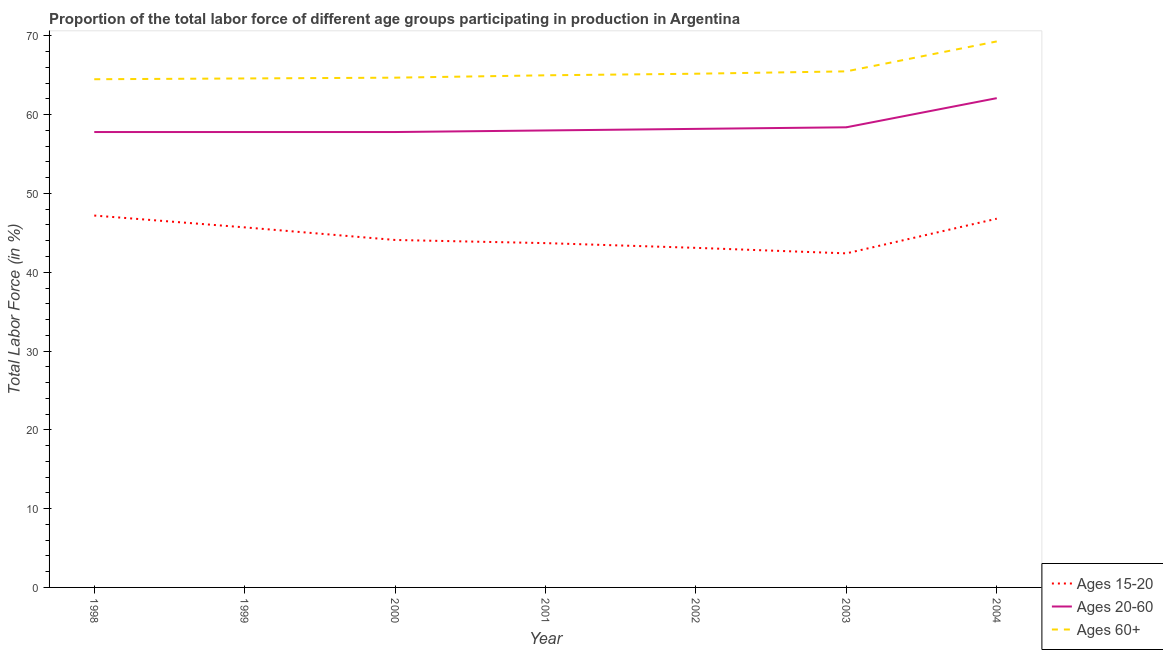Does the line corresponding to percentage of labor force within the age group 15-20 intersect with the line corresponding to percentage of labor force within the age group 20-60?
Provide a short and direct response. No. Is the number of lines equal to the number of legend labels?
Your answer should be compact. Yes. What is the percentage of labor force above age 60 in 1999?
Ensure brevity in your answer.  64.6. Across all years, what is the maximum percentage of labor force within the age group 20-60?
Make the answer very short. 62.1. Across all years, what is the minimum percentage of labor force within the age group 20-60?
Offer a terse response. 57.8. In which year was the percentage of labor force within the age group 20-60 maximum?
Provide a short and direct response. 2004. In which year was the percentage of labor force above age 60 minimum?
Provide a short and direct response. 1998. What is the total percentage of labor force within the age group 15-20 in the graph?
Provide a short and direct response. 313. What is the difference between the percentage of labor force above age 60 in 1999 and that in 2000?
Ensure brevity in your answer.  -0.1. What is the difference between the percentage of labor force above age 60 in 2004 and the percentage of labor force within the age group 15-20 in 2001?
Your answer should be compact. 25.6. What is the average percentage of labor force within the age group 20-60 per year?
Provide a succinct answer. 58.59. In the year 1998, what is the difference between the percentage of labor force above age 60 and percentage of labor force within the age group 20-60?
Offer a very short reply. 6.7. What is the ratio of the percentage of labor force within the age group 15-20 in 1998 to that in 2002?
Make the answer very short. 1.1. What is the difference between the highest and the second highest percentage of labor force within the age group 15-20?
Make the answer very short. 0.4. What is the difference between the highest and the lowest percentage of labor force within the age group 20-60?
Ensure brevity in your answer.  4.3. Is the sum of the percentage of labor force within the age group 15-20 in 2000 and 2002 greater than the maximum percentage of labor force above age 60 across all years?
Provide a short and direct response. Yes. Does the percentage of labor force within the age group 15-20 monotonically increase over the years?
Keep it short and to the point. No. Is the percentage of labor force within the age group 20-60 strictly less than the percentage of labor force within the age group 15-20 over the years?
Offer a terse response. No. Are the values on the major ticks of Y-axis written in scientific E-notation?
Your response must be concise. No. Does the graph contain any zero values?
Provide a short and direct response. No. Does the graph contain grids?
Offer a terse response. No. What is the title of the graph?
Make the answer very short. Proportion of the total labor force of different age groups participating in production in Argentina. Does "Transport" appear as one of the legend labels in the graph?
Keep it short and to the point. No. What is the label or title of the Y-axis?
Keep it short and to the point. Total Labor Force (in %). What is the Total Labor Force (in %) in Ages 15-20 in 1998?
Offer a terse response. 47.2. What is the Total Labor Force (in %) of Ages 20-60 in 1998?
Offer a terse response. 57.8. What is the Total Labor Force (in %) of Ages 60+ in 1998?
Keep it short and to the point. 64.5. What is the Total Labor Force (in %) in Ages 15-20 in 1999?
Offer a terse response. 45.7. What is the Total Labor Force (in %) of Ages 20-60 in 1999?
Offer a very short reply. 57.8. What is the Total Labor Force (in %) in Ages 60+ in 1999?
Provide a short and direct response. 64.6. What is the Total Labor Force (in %) of Ages 15-20 in 2000?
Give a very brief answer. 44.1. What is the Total Labor Force (in %) of Ages 20-60 in 2000?
Your answer should be compact. 57.8. What is the Total Labor Force (in %) in Ages 60+ in 2000?
Give a very brief answer. 64.7. What is the Total Labor Force (in %) of Ages 15-20 in 2001?
Your answer should be compact. 43.7. What is the Total Labor Force (in %) of Ages 20-60 in 2001?
Provide a short and direct response. 58. What is the Total Labor Force (in %) in Ages 60+ in 2001?
Ensure brevity in your answer.  65. What is the Total Labor Force (in %) in Ages 15-20 in 2002?
Provide a succinct answer. 43.1. What is the Total Labor Force (in %) of Ages 20-60 in 2002?
Make the answer very short. 58.2. What is the Total Labor Force (in %) of Ages 60+ in 2002?
Provide a short and direct response. 65.2. What is the Total Labor Force (in %) of Ages 15-20 in 2003?
Make the answer very short. 42.4. What is the Total Labor Force (in %) of Ages 20-60 in 2003?
Your answer should be very brief. 58.4. What is the Total Labor Force (in %) in Ages 60+ in 2003?
Offer a very short reply. 65.5. What is the Total Labor Force (in %) of Ages 15-20 in 2004?
Provide a short and direct response. 46.8. What is the Total Labor Force (in %) of Ages 20-60 in 2004?
Offer a very short reply. 62.1. What is the Total Labor Force (in %) of Ages 60+ in 2004?
Your answer should be compact. 69.3. Across all years, what is the maximum Total Labor Force (in %) of Ages 15-20?
Your response must be concise. 47.2. Across all years, what is the maximum Total Labor Force (in %) in Ages 20-60?
Ensure brevity in your answer.  62.1. Across all years, what is the maximum Total Labor Force (in %) of Ages 60+?
Your answer should be very brief. 69.3. Across all years, what is the minimum Total Labor Force (in %) in Ages 15-20?
Provide a succinct answer. 42.4. Across all years, what is the minimum Total Labor Force (in %) of Ages 20-60?
Your response must be concise. 57.8. Across all years, what is the minimum Total Labor Force (in %) in Ages 60+?
Provide a succinct answer. 64.5. What is the total Total Labor Force (in %) in Ages 15-20 in the graph?
Your answer should be compact. 313. What is the total Total Labor Force (in %) in Ages 20-60 in the graph?
Provide a short and direct response. 410.1. What is the total Total Labor Force (in %) in Ages 60+ in the graph?
Your answer should be compact. 458.8. What is the difference between the Total Labor Force (in %) of Ages 15-20 in 1998 and that in 1999?
Ensure brevity in your answer.  1.5. What is the difference between the Total Labor Force (in %) in Ages 60+ in 1998 and that in 1999?
Keep it short and to the point. -0.1. What is the difference between the Total Labor Force (in %) of Ages 15-20 in 1998 and that in 2000?
Offer a terse response. 3.1. What is the difference between the Total Labor Force (in %) of Ages 20-60 in 1998 and that in 2001?
Provide a short and direct response. -0.2. What is the difference between the Total Labor Force (in %) of Ages 60+ in 1998 and that in 2001?
Your response must be concise. -0.5. What is the difference between the Total Labor Force (in %) of Ages 15-20 in 1998 and that in 2002?
Your answer should be very brief. 4.1. What is the difference between the Total Labor Force (in %) in Ages 20-60 in 1998 and that in 2002?
Provide a succinct answer. -0.4. What is the difference between the Total Labor Force (in %) in Ages 60+ in 1998 and that in 2002?
Provide a succinct answer. -0.7. What is the difference between the Total Labor Force (in %) in Ages 60+ in 1998 and that in 2003?
Your answer should be compact. -1. What is the difference between the Total Labor Force (in %) in Ages 60+ in 1998 and that in 2004?
Give a very brief answer. -4.8. What is the difference between the Total Labor Force (in %) of Ages 15-20 in 1999 and that in 2000?
Keep it short and to the point. 1.6. What is the difference between the Total Labor Force (in %) of Ages 60+ in 1999 and that in 2001?
Offer a terse response. -0.4. What is the difference between the Total Labor Force (in %) of Ages 20-60 in 1999 and that in 2002?
Your answer should be very brief. -0.4. What is the difference between the Total Labor Force (in %) of Ages 20-60 in 1999 and that in 2003?
Provide a succinct answer. -0.6. What is the difference between the Total Labor Force (in %) of Ages 60+ in 1999 and that in 2003?
Your answer should be compact. -0.9. What is the difference between the Total Labor Force (in %) of Ages 20-60 in 1999 and that in 2004?
Your answer should be compact. -4.3. What is the difference between the Total Labor Force (in %) of Ages 15-20 in 2000 and that in 2001?
Give a very brief answer. 0.4. What is the difference between the Total Labor Force (in %) in Ages 15-20 in 2000 and that in 2002?
Offer a terse response. 1. What is the difference between the Total Labor Force (in %) in Ages 60+ in 2000 and that in 2002?
Provide a succinct answer. -0.5. What is the difference between the Total Labor Force (in %) in Ages 15-20 in 2000 and that in 2003?
Offer a very short reply. 1.7. What is the difference between the Total Labor Force (in %) in Ages 20-60 in 2000 and that in 2003?
Your answer should be very brief. -0.6. What is the difference between the Total Labor Force (in %) of Ages 15-20 in 2000 and that in 2004?
Offer a very short reply. -2.7. What is the difference between the Total Labor Force (in %) in Ages 20-60 in 2000 and that in 2004?
Provide a succinct answer. -4.3. What is the difference between the Total Labor Force (in %) in Ages 15-20 in 2001 and that in 2002?
Offer a terse response. 0.6. What is the difference between the Total Labor Force (in %) of Ages 20-60 in 2001 and that in 2002?
Offer a very short reply. -0.2. What is the difference between the Total Labor Force (in %) of Ages 60+ in 2001 and that in 2002?
Make the answer very short. -0.2. What is the difference between the Total Labor Force (in %) of Ages 60+ in 2001 and that in 2003?
Make the answer very short. -0.5. What is the difference between the Total Labor Force (in %) in Ages 60+ in 2001 and that in 2004?
Keep it short and to the point. -4.3. What is the difference between the Total Labor Force (in %) of Ages 20-60 in 2002 and that in 2003?
Keep it short and to the point. -0.2. What is the difference between the Total Labor Force (in %) in Ages 60+ in 2002 and that in 2003?
Your answer should be compact. -0.3. What is the difference between the Total Labor Force (in %) of Ages 15-20 in 1998 and the Total Labor Force (in %) of Ages 60+ in 1999?
Ensure brevity in your answer.  -17.4. What is the difference between the Total Labor Force (in %) of Ages 20-60 in 1998 and the Total Labor Force (in %) of Ages 60+ in 1999?
Provide a succinct answer. -6.8. What is the difference between the Total Labor Force (in %) of Ages 15-20 in 1998 and the Total Labor Force (in %) of Ages 60+ in 2000?
Provide a succinct answer. -17.5. What is the difference between the Total Labor Force (in %) of Ages 15-20 in 1998 and the Total Labor Force (in %) of Ages 20-60 in 2001?
Provide a short and direct response. -10.8. What is the difference between the Total Labor Force (in %) in Ages 15-20 in 1998 and the Total Labor Force (in %) in Ages 60+ in 2001?
Give a very brief answer. -17.8. What is the difference between the Total Labor Force (in %) in Ages 20-60 in 1998 and the Total Labor Force (in %) in Ages 60+ in 2001?
Ensure brevity in your answer.  -7.2. What is the difference between the Total Labor Force (in %) of Ages 15-20 in 1998 and the Total Labor Force (in %) of Ages 20-60 in 2002?
Ensure brevity in your answer.  -11. What is the difference between the Total Labor Force (in %) in Ages 15-20 in 1998 and the Total Labor Force (in %) in Ages 60+ in 2002?
Provide a short and direct response. -18. What is the difference between the Total Labor Force (in %) in Ages 20-60 in 1998 and the Total Labor Force (in %) in Ages 60+ in 2002?
Your response must be concise. -7.4. What is the difference between the Total Labor Force (in %) in Ages 15-20 in 1998 and the Total Labor Force (in %) in Ages 60+ in 2003?
Your response must be concise. -18.3. What is the difference between the Total Labor Force (in %) in Ages 15-20 in 1998 and the Total Labor Force (in %) in Ages 20-60 in 2004?
Your response must be concise. -14.9. What is the difference between the Total Labor Force (in %) in Ages 15-20 in 1998 and the Total Labor Force (in %) in Ages 60+ in 2004?
Offer a terse response. -22.1. What is the difference between the Total Labor Force (in %) in Ages 20-60 in 1998 and the Total Labor Force (in %) in Ages 60+ in 2004?
Offer a terse response. -11.5. What is the difference between the Total Labor Force (in %) in Ages 15-20 in 1999 and the Total Labor Force (in %) in Ages 20-60 in 2000?
Your answer should be very brief. -12.1. What is the difference between the Total Labor Force (in %) of Ages 20-60 in 1999 and the Total Labor Force (in %) of Ages 60+ in 2000?
Your response must be concise. -6.9. What is the difference between the Total Labor Force (in %) of Ages 15-20 in 1999 and the Total Labor Force (in %) of Ages 60+ in 2001?
Ensure brevity in your answer.  -19.3. What is the difference between the Total Labor Force (in %) in Ages 15-20 in 1999 and the Total Labor Force (in %) in Ages 60+ in 2002?
Offer a terse response. -19.5. What is the difference between the Total Labor Force (in %) in Ages 20-60 in 1999 and the Total Labor Force (in %) in Ages 60+ in 2002?
Make the answer very short. -7.4. What is the difference between the Total Labor Force (in %) in Ages 15-20 in 1999 and the Total Labor Force (in %) in Ages 20-60 in 2003?
Your response must be concise. -12.7. What is the difference between the Total Labor Force (in %) of Ages 15-20 in 1999 and the Total Labor Force (in %) of Ages 60+ in 2003?
Your response must be concise. -19.8. What is the difference between the Total Labor Force (in %) in Ages 20-60 in 1999 and the Total Labor Force (in %) in Ages 60+ in 2003?
Provide a short and direct response. -7.7. What is the difference between the Total Labor Force (in %) of Ages 15-20 in 1999 and the Total Labor Force (in %) of Ages 20-60 in 2004?
Keep it short and to the point. -16.4. What is the difference between the Total Labor Force (in %) in Ages 15-20 in 1999 and the Total Labor Force (in %) in Ages 60+ in 2004?
Ensure brevity in your answer.  -23.6. What is the difference between the Total Labor Force (in %) of Ages 20-60 in 1999 and the Total Labor Force (in %) of Ages 60+ in 2004?
Your answer should be very brief. -11.5. What is the difference between the Total Labor Force (in %) in Ages 15-20 in 2000 and the Total Labor Force (in %) in Ages 60+ in 2001?
Offer a terse response. -20.9. What is the difference between the Total Labor Force (in %) in Ages 15-20 in 2000 and the Total Labor Force (in %) in Ages 20-60 in 2002?
Your response must be concise. -14.1. What is the difference between the Total Labor Force (in %) of Ages 15-20 in 2000 and the Total Labor Force (in %) of Ages 60+ in 2002?
Offer a terse response. -21.1. What is the difference between the Total Labor Force (in %) of Ages 15-20 in 2000 and the Total Labor Force (in %) of Ages 20-60 in 2003?
Provide a succinct answer. -14.3. What is the difference between the Total Labor Force (in %) in Ages 15-20 in 2000 and the Total Labor Force (in %) in Ages 60+ in 2003?
Provide a succinct answer. -21.4. What is the difference between the Total Labor Force (in %) in Ages 15-20 in 2000 and the Total Labor Force (in %) in Ages 60+ in 2004?
Your answer should be compact. -25.2. What is the difference between the Total Labor Force (in %) in Ages 20-60 in 2000 and the Total Labor Force (in %) in Ages 60+ in 2004?
Ensure brevity in your answer.  -11.5. What is the difference between the Total Labor Force (in %) in Ages 15-20 in 2001 and the Total Labor Force (in %) in Ages 20-60 in 2002?
Ensure brevity in your answer.  -14.5. What is the difference between the Total Labor Force (in %) in Ages 15-20 in 2001 and the Total Labor Force (in %) in Ages 60+ in 2002?
Provide a short and direct response. -21.5. What is the difference between the Total Labor Force (in %) in Ages 15-20 in 2001 and the Total Labor Force (in %) in Ages 20-60 in 2003?
Ensure brevity in your answer.  -14.7. What is the difference between the Total Labor Force (in %) of Ages 15-20 in 2001 and the Total Labor Force (in %) of Ages 60+ in 2003?
Your answer should be compact. -21.8. What is the difference between the Total Labor Force (in %) in Ages 20-60 in 2001 and the Total Labor Force (in %) in Ages 60+ in 2003?
Keep it short and to the point. -7.5. What is the difference between the Total Labor Force (in %) of Ages 15-20 in 2001 and the Total Labor Force (in %) of Ages 20-60 in 2004?
Keep it short and to the point. -18.4. What is the difference between the Total Labor Force (in %) of Ages 15-20 in 2001 and the Total Labor Force (in %) of Ages 60+ in 2004?
Make the answer very short. -25.6. What is the difference between the Total Labor Force (in %) in Ages 15-20 in 2002 and the Total Labor Force (in %) in Ages 20-60 in 2003?
Make the answer very short. -15.3. What is the difference between the Total Labor Force (in %) in Ages 15-20 in 2002 and the Total Labor Force (in %) in Ages 60+ in 2003?
Keep it short and to the point. -22.4. What is the difference between the Total Labor Force (in %) in Ages 20-60 in 2002 and the Total Labor Force (in %) in Ages 60+ in 2003?
Ensure brevity in your answer.  -7.3. What is the difference between the Total Labor Force (in %) of Ages 15-20 in 2002 and the Total Labor Force (in %) of Ages 60+ in 2004?
Ensure brevity in your answer.  -26.2. What is the difference between the Total Labor Force (in %) of Ages 15-20 in 2003 and the Total Labor Force (in %) of Ages 20-60 in 2004?
Give a very brief answer. -19.7. What is the difference between the Total Labor Force (in %) of Ages 15-20 in 2003 and the Total Labor Force (in %) of Ages 60+ in 2004?
Your response must be concise. -26.9. What is the difference between the Total Labor Force (in %) in Ages 20-60 in 2003 and the Total Labor Force (in %) in Ages 60+ in 2004?
Provide a succinct answer. -10.9. What is the average Total Labor Force (in %) of Ages 15-20 per year?
Your answer should be very brief. 44.71. What is the average Total Labor Force (in %) in Ages 20-60 per year?
Provide a short and direct response. 58.59. What is the average Total Labor Force (in %) of Ages 60+ per year?
Ensure brevity in your answer.  65.54. In the year 1998, what is the difference between the Total Labor Force (in %) of Ages 15-20 and Total Labor Force (in %) of Ages 20-60?
Offer a terse response. -10.6. In the year 1998, what is the difference between the Total Labor Force (in %) in Ages 15-20 and Total Labor Force (in %) in Ages 60+?
Make the answer very short. -17.3. In the year 1999, what is the difference between the Total Labor Force (in %) in Ages 15-20 and Total Labor Force (in %) in Ages 20-60?
Your response must be concise. -12.1. In the year 1999, what is the difference between the Total Labor Force (in %) in Ages 15-20 and Total Labor Force (in %) in Ages 60+?
Give a very brief answer. -18.9. In the year 2000, what is the difference between the Total Labor Force (in %) in Ages 15-20 and Total Labor Force (in %) in Ages 20-60?
Provide a succinct answer. -13.7. In the year 2000, what is the difference between the Total Labor Force (in %) of Ages 15-20 and Total Labor Force (in %) of Ages 60+?
Ensure brevity in your answer.  -20.6. In the year 2000, what is the difference between the Total Labor Force (in %) of Ages 20-60 and Total Labor Force (in %) of Ages 60+?
Ensure brevity in your answer.  -6.9. In the year 2001, what is the difference between the Total Labor Force (in %) in Ages 15-20 and Total Labor Force (in %) in Ages 20-60?
Provide a succinct answer. -14.3. In the year 2001, what is the difference between the Total Labor Force (in %) in Ages 15-20 and Total Labor Force (in %) in Ages 60+?
Give a very brief answer. -21.3. In the year 2001, what is the difference between the Total Labor Force (in %) of Ages 20-60 and Total Labor Force (in %) of Ages 60+?
Your answer should be very brief. -7. In the year 2002, what is the difference between the Total Labor Force (in %) in Ages 15-20 and Total Labor Force (in %) in Ages 20-60?
Offer a very short reply. -15.1. In the year 2002, what is the difference between the Total Labor Force (in %) of Ages 15-20 and Total Labor Force (in %) of Ages 60+?
Ensure brevity in your answer.  -22.1. In the year 2003, what is the difference between the Total Labor Force (in %) in Ages 15-20 and Total Labor Force (in %) in Ages 60+?
Make the answer very short. -23.1. In the year 2003, what is the difference between the Total Labor Force (in %) of Ages 20-60 and Total Labor Force (in %) of Ages 60+?
Ensure brevity in your answer.  -7.1. In the year 2004, what is the difference between the Total Labor Force (in %) of Ages 15-20 and Total Labor Force (in %) of Ages 20-60?
Offer a terse response. -15.3. In the year 2004, what is the difference between the Total Labor Force (in %) of Ages 15-20 and Total Labor Force (in %) of Ages 60+?
Give a very brief answer. -22.5. What is the ratio of the Total Labor Force (in %) in Ages 15-20 in 1998 to that in 1999?
Make the answer very short. 1.03. What is the ratio of the Total Labor Force (in %) of Ages 60+ in 1998 to that in 1999?
Offer a very short reply. 1. What is the ratio of the Total Labor Force (in %) of Ages 15-20 in 1998 to that in 2000?
Give a very brief answer. 1.07. What is the ratio of the Total Labor Force (in %) of Ages 20-60 in 1998 to that in 2000?
Provide a short and direct response. 1. What is the ratio of the Total Labor Force (in %) in Ages 15-20 in 1998 to that in 2001?
Provide a short and direct response. 1.08. What is the ratio of the Total Labor Force (in %) in Ages 20-60 in 1998 to that in 2001?
Provide a short and direct response. 1. What is the ratio of the Total Labor Force (in %) of Ages 60+ in 1998 to that in 2001?
Make the answer very short. 0.99. What is the ratio of the Total Labor Force (in %) of Ages 15-20 in 1998 to that in 2002?
Offer a terse response. 1.1. What is the ratio of the Total Labor Force (in %) of Ages 60+ in 1998 to that in 2002?
Provide a short and direct response. 0.99. What is the ratio of the Total Labor Force (in %) of Ages 15-20 in 1998 to that in 2003?
Your answer should be very brief. 1.11. What is the ratio of the Total Labor Force (in %) in Ages 20-60 in 1998 to that in 2003?
Make the answer very short. 0.99. What is the ratio of the Total Labor Force (in %) in Ages 60+ in 1998 to that in 2003?
Provide a short and direct response. 0.98. What is the ratio of the Total Labor Force (in %) of Ages 15-20 in 1998 to that in 2004?
Offer a terse response. 1.01. What is the ratio of the Total Labor Force (in %) in Ages 20-60 in 1998 to that in 2004?
Offer a terse response. 0.93. What is the ratio of the Total Labor Force (in %) of Ages 60+ in 1998 to that in 2004?
Make the answer very short. 0.93. What is the ratio of the Total Labor Force (in %) of Ages 15-20 in 1999 to that in 2000?
Provide a succinct answer. 1.04. What is the ratio of the Total Labor Force (in %) in Ages 15-20 in 1999 to that in 2001?
Provide a short and direct response. 1.05. What is the ratio of the Total Labor Force (in %) of Ages 20-60 in 1999 to that in 2001?
Your answer should be compact. 1. What is the ratio of the Total Labor Force (in %) of Ages 60+ in 1999 to that in 2001?
Offer a terse response. 0.99. What is the ratio of the Total Labor Force (in %) in Ages 15-20 in 1999 to that in 2002?
Provide a succinct answer. 1.06. What is the ratio of the Total Labor Force (in %) of Ages 60+ in 1999 to that in 2002?
Offer a terse response. 0.99. What is the ratio of the Total Labor Force (in %) in Ages 15-20 in 1999 to that in 2003?
Ensure brevity in your answer.  1.08. What is the ratio of the Total Labor Force (in %) in Ages 20-60 in 1999 to that in 2003?
Provide a succinct answer. 0.99. What is the ratio of the Total Labor Force (in %) in Ages 60+ in 1999 to that in 2003?
Ensure brevity in your answer.  0.99. What is the ratio of the Total Labor Force (in %) of Ages 15-20 in 1999 to that in 2004?
Your answer should be compact. 0.98. What is the ratio of the Total Labor Force (in %) in Ages 20-60 in 1999 to that in 2004?
Your answer should be compact. 0.93. What is the ratio of the Total Labor Force (in %) in Ages 60+ in 1999 to that in 2004?
Offer a terse response. 0.93. What is the ratio of the Total Labor Force (in %) in Ages 15-20 in 2000 to that in 2001?
Ensure brevity in your answer.  1.01. What is the ratio of the Total Labor Force (in %) of Ages 15-20 in 2000 to that in 2002?
Give a very brief answer. 1.02. What is the ratio of the Total Labor Force (in %) of Ages 60+ in 2000 to that in 2002?
Provide a short and direct response. 0.99. What is the ratio of the Total Labor Force (in %) of Ages 15-20 in 2000 to that in 2003?
Your answer should be compact. 1.04. What is the ratio of the Total Labor Force (in %) in Ages 60+ in 2000 to that in 2003?
Your answer should be very brief. 0.99. What is the ratio of the Total Labor Force (in %) in Ages 15-20 in 2000 to that in 2004?
Your answer should be very brief. 0.94. What is the ratio of the Total Labor Force (in %) of Ages 20-60 in 2000 to that in 2004?
Your answer should be compact. 0.93. What is the ratio of the Total Labor Force (in %) of Ages 60+ in 2000 to that in 2004?
Offer a very short reply. 0.93. What is the ratio of the Total Labor Force (in %) of Ages 15-20 in 2001 to that in 2002?
Offer a very short reply. 1.01. What is the ratio of the Total Labor Force (in %) in Ages 20-60 in 2001 to that in 2002?
Ensure brevity in your answer.  1. What is the ratio of the Total Labor Force (in %) in Ages 60+ in 2001 to that in 2002?
Your response must be concise. 1. What is the ratio of the Total Labor Force (in %) in Ages 15-20 in 2001 to that in 2003?
Ensure brevity in your answer.  1.03. What is the ratio of the Total Labor Force (in %) in Ages 20-60 in 2001 to that in 2003?
Your response must be concise. 0.99. What is the ratio of the Total Labor Force (in %) of Ages 60+ in 2001 to that in 2003?
Give a very brief answer. 0.99. What is the ratio of the Total Labor Force (in %) in Ages 15-20 in 2001 to that in 2004?
Offer a terse response. 0.93. What is the ratio of the Total Labor Force (in %) of Ages 20-60 in 2001 to that in 2004?
Give a very brief answer. 0.93. What is the ratio of the Total Labor Force (in %) of Ages 60+ in 2001 to that in 2004?
Your response must be concise. 0.94. What is the ratio of the Total Labor Force (in %) of Ages 15-20 in 2002 to that in 2003?
Make the answer very short. 1.02. What is the ratio of the Total Labor Force (in %) in Ages 15-20 in 2002 to that in 2004?
Make the answer very short. 0.92. What is the ratio of the Total Labor Force (in %) of Ages 20-60 in 2002 to that in 2004?
Keep it short and to the point. 0.94. What is the ratio of the Total Labor Force (in %) in Ages 60+ in 2002 to that in 2004?
Offer a terse response. 0.94. What is the ratio of the Total Labor Force (in %) in Ages 15-20 in 2003 to that in 2004?
Offer a very short reply. 0.91. What is the ratio of the Total Labor Force (in %) of Ages 20-60 in 2003 to that in 2004?
Provide a short and direct response. 0.94. What is the ratio of the Total Labor Force (in %) of Ages 60+ in 2003 to that in 2004?
Provide a short and direct response. 0.95. What is the difference between the highest and the second highest Total Labor Force (in %) in Ages 20-60?
Keep it short and to the point. 3.7. What is the difference between the highest and the second highest Total Labor Force (in %) in Ages 60+?
Your answer should be compact. 3.8. 